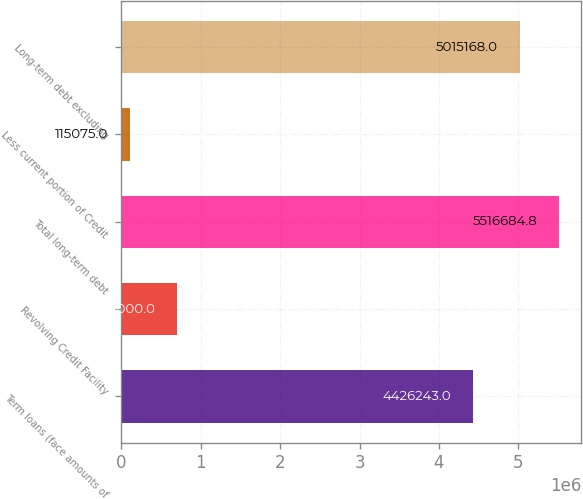Convert chart. <chart><loc_0><loc_0><loc_500><loc_500><bar_chart><fcel>Term loans (face amounts of<fcel>Revolving Credit Facility<fcel>Total long-term debt<fcel>Less current portion of Credit<fcel>Long-term debt excluding<nl><fcel>4.42624e+06<fcel>704000<fcel>5.51668e+06<fcel>115075<fcel>5.01517e+06<nl></chart> 